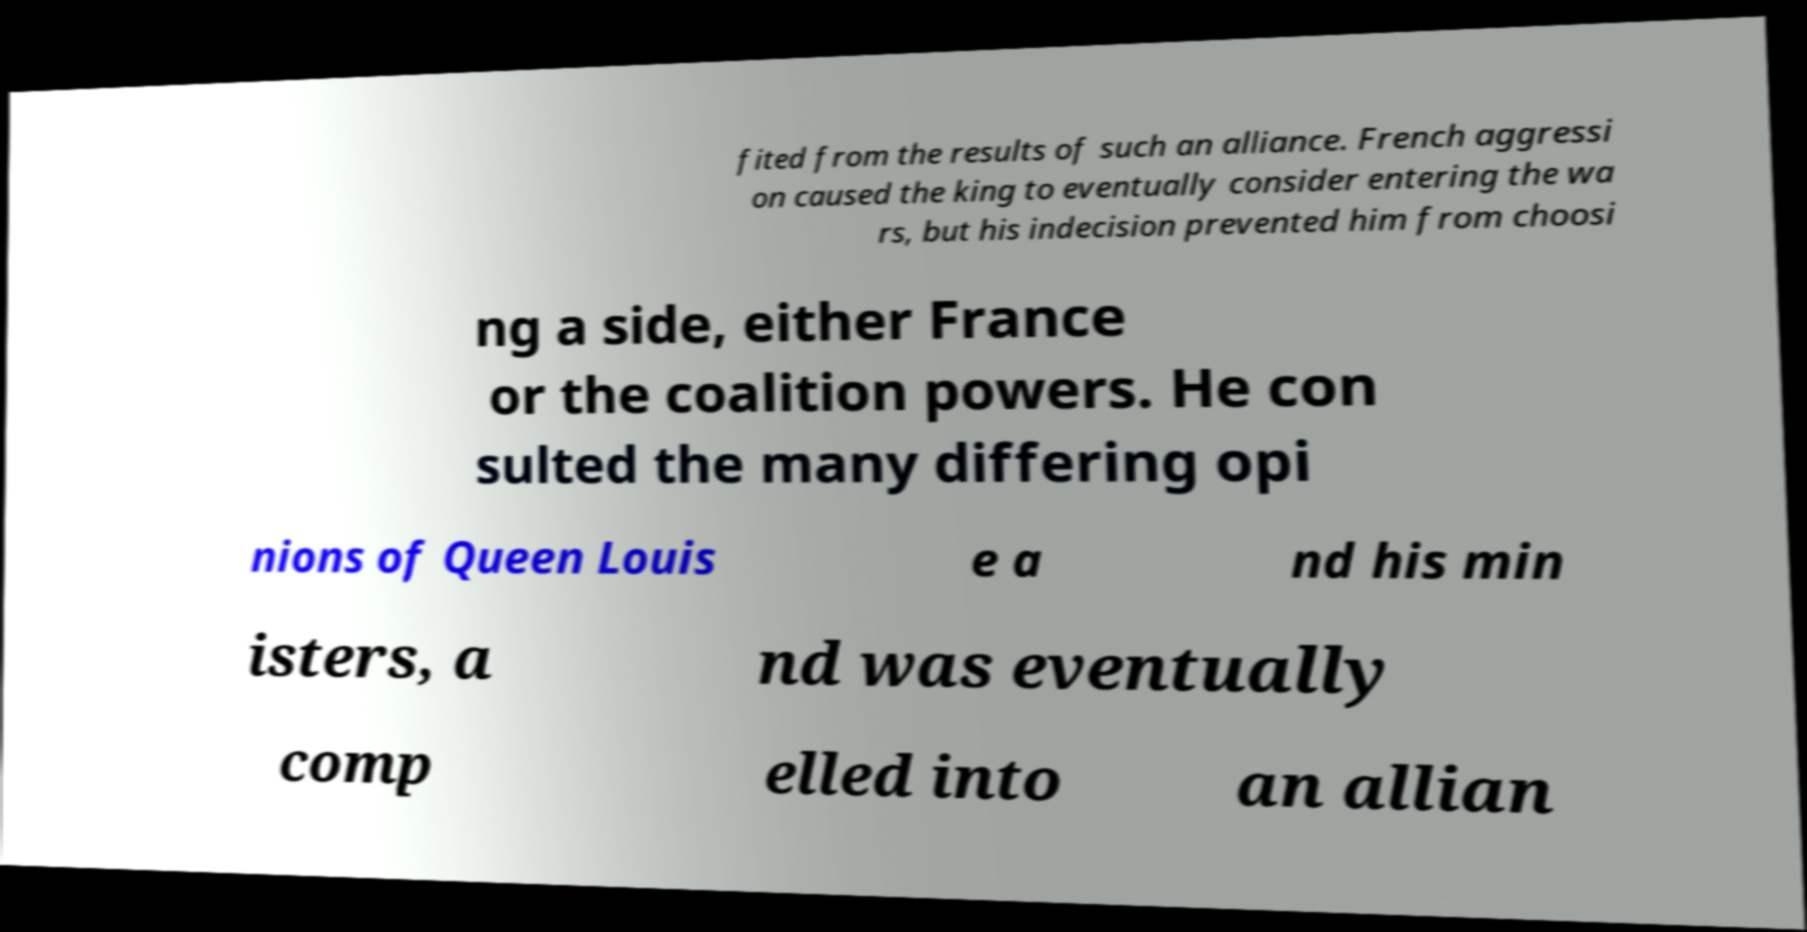What messages or text are displayed in this image? I need them in a readable, typed format. fited from the results of such an alliance. French aggressi on caused the king to eventually consider entering the wa rs, but his indecision prevented him from choosi ng a side, either France or the coalition powers. He con sulted the many differing opi nions of Queen Louis e a nd his min isters, a nd was eventually comp elled into an allian 